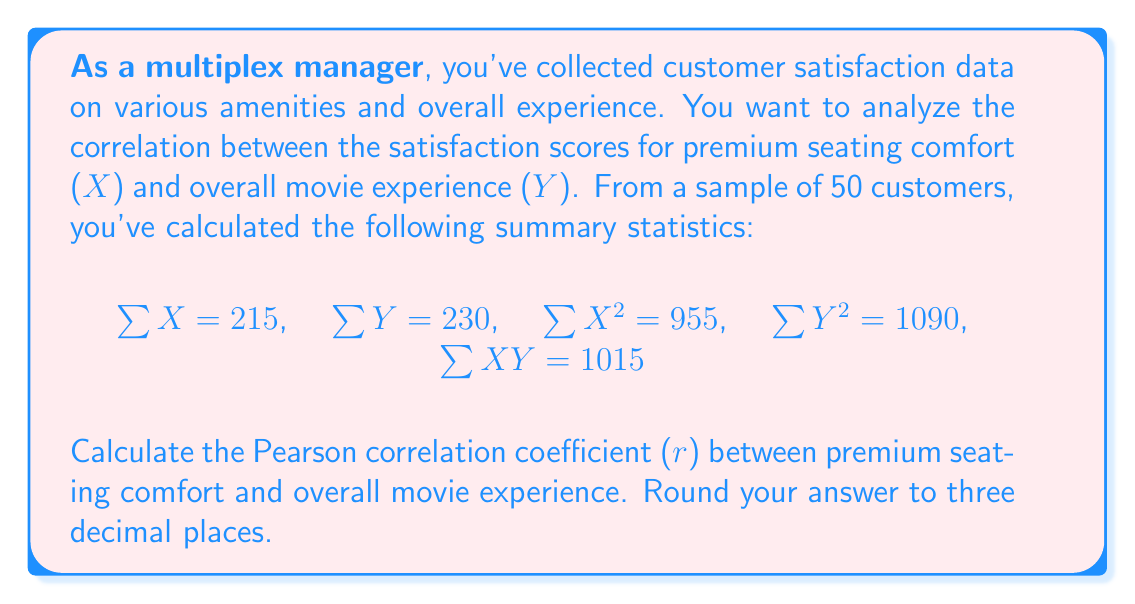Help me with this question. To calculate the Pearson correlation coefficient (r), we'll use the formula:

$$r = \frac{n\sum XY - \sum X \sum Y}{\sqrt{[n\sum X^2 - (\sum X)^2][n\sum Y^2 - (\sum Y)^2]}}$$

Where n is the sample size (50 in this case).

Step 1: Calculate $n\sum XY$
$50 \times 1015 = 50750$

Step 2: Calculate $\sum X \sum Y$
$215 \times 230 = 49450$

Step 3: Calculate the numerator
$50750 - 49450 = 1300$

Step 4: Calculate $n\sum X^2$ and $(\sum X)^2$
$n\sum X^2 = 50 \times 955 = 47750$
$(\sum X)^2 = 215^2 = 46225$

Step 5: Calculate $n\sum Y^2$ and $(\sum Y)^2$
$n\sum Y^2 = 50 \times 1090 = 54500$
$(\sum Y)^2 = 230^2 = 52900$

Step 6: Calculate the denominator
$\sqrt{(47750 - 46225)(54500 - 52900)} = \sqrt{1525 \times 1600} = \sqrt{2440000} = 1562.05$

Step 7: Divide the numerator by the denominator
$r = \frac{1300}{1562.05} = 0.8322$

Step 8: Round to three decimal places
$r = 0.832$
Answer: 0.832 